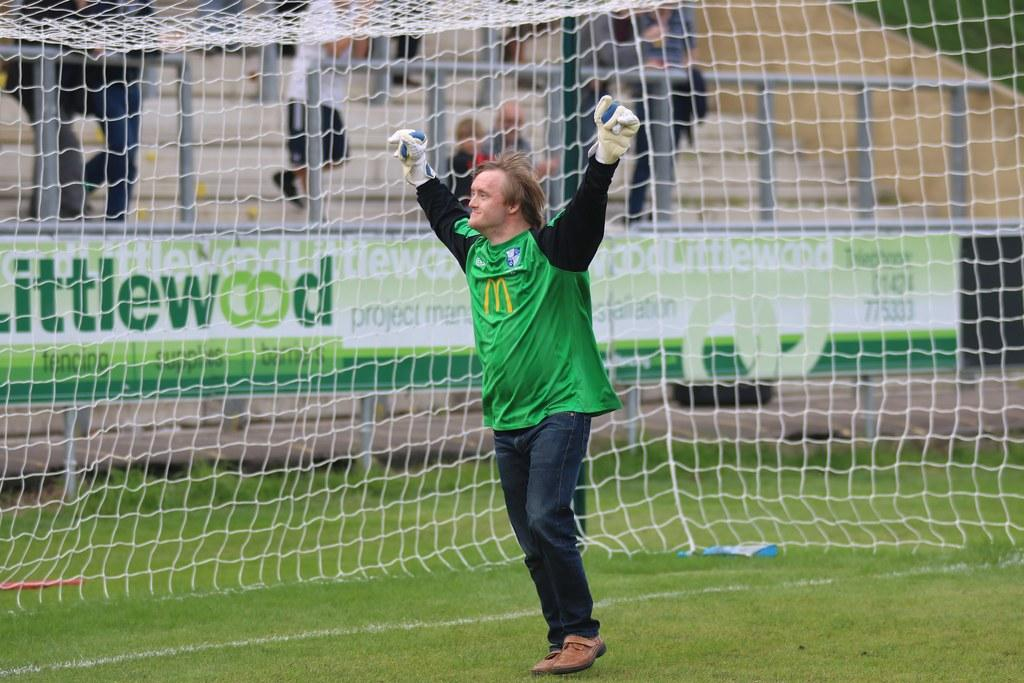<image>
Give a short and clear explanation of the subsequent image. The goalkeeper celebrates behind a banner that reads Littlewood. 